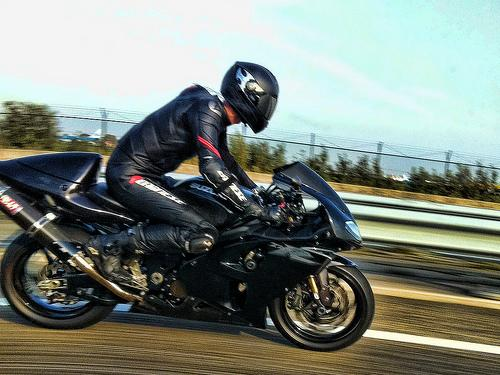Can you tell me about the overall subject of the image and the key action happening in it? A person is riding a black motorcycle along a highway, wearing a black helmet, suit, gloves, and boots, with the motorcycle's wheels in motion. Analyze this image for its aesthetic appeal and the subject's posture. The image has a visually appealing composition with the person riding the motorcycle, seated firmly and balanced, displaying good posture in their attire, and the surrounding scenery adds interest and beauty to the overall picture. Describe the relationship between the motorcycle and the objects around it. The motorcycle is interacting with the road as it moves forward, passing by the guardrail, plants, and white stripe, while the rider is seated on the black seat and holding the handle, and a bridge and mountain range serve as a backdrop. What emotions or feelings may be experienced while viewing the image? The image conveys a sense of freedom, adventure, and excitement, given the person riding a fast-moving motorcycle along a scenic highway. 